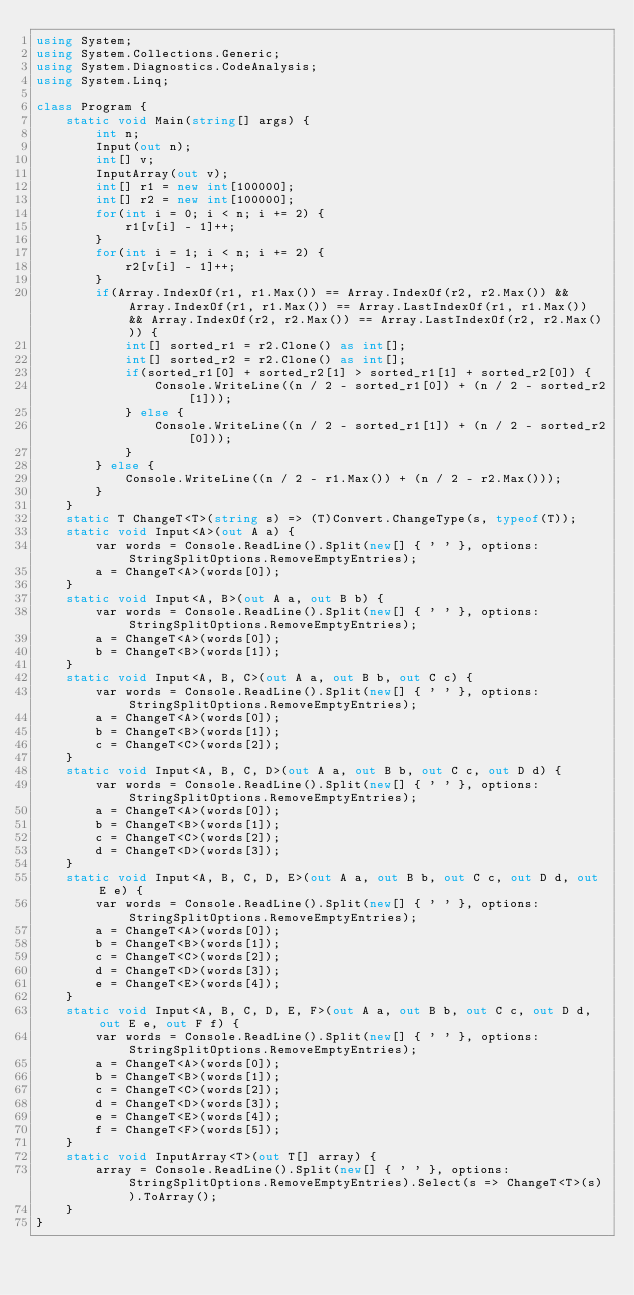<code> <loc_0><loc_0><loc_500><loc_500><_C#_>using System;
using System.Collections.Generic;
using System.Diagnostics.CodeAnalysis;
using System.Linq;

class Program {
    static void Main(string[] args) {
        int n;
        Input(out n);
        int[] v;
        InputArray(out v);
        int[] r1 = new int[100000];
        int[] r2 = new int[100000];
        for(int i = 0; i < n; i += 2) {
            r1[v[i] - 1]++;
        }
        for(int i = 1; i < n; i += 2) {
            r2[v[i] - 1]++;
        }
        if(Array.IndexOf(r1, r1.Max()) == Array.IndexOf(r2, r2.Max()) && Array.IndexOf(r1, r1.Max()) == Array.LastIndexOf(r1, r1.Max()) && Array.IndexOf(r2, r2.Max()) == Array.LastIndexOf(r2, r2.Max())) {
            int[] sorted_r1 = r2.Clone() as int[];
            int[] sorted_r2 = r2.Clone() as int[];
            if(sorted_r1[0] + sorted_r2[1] > sorted_r1[1] + sorted_r2[0]) {
                Console.WriteLine((n / 2 - sorted_r1[0]) + (n / 2 - sorted_r2[1]));
            } else {
                Console.WriteLine((n / 2 - sorted_r1[1]) + (n / 2 - sorted_r2[0]));
            }
        } else {
            Console.WriteLine((n / 2 - r1.Max()) + (n / 2 - r2.Max()));
        }
    }
    static T ChangeT<T>(string s) => (T)Convert.ChangeType(s, typeof(T));
    static void Input<A>(out A a) {
        var words = Console.ReadLine().Split(new[] { ' ' }, options: StringSplitOptions.RemoveEmptyEntries);
        a = ChangeT<A>(words[0]);
    }
    static void Input<A, B>(out A a, out B b) {
        var words = Console.ReadLine().Split(new[] { ' ' }, options: StringSplitOptions.RemoveEmptyEntries);
        a = ChangeT<A>(words[0]);
        b = ChangeT<B>(words[1]);
    }
    static void Input<A, B, C>(out A a, out B b, out C c) {
        var words = Console.ReadLine().Split(new[] { ' ' }, options: StringSplitOptions.RemoveEmptyEntries);
        a = ChangeT<A>(words[0]);
        b = ChangeT<B>(words[1]);
        c = ChangeT<C>(words[2]);
    }
    static void Input<A, B, C, D>(out A a, out B b, out C c, out D d) {
        var words = Console.ReadLine().Split(new[] { ' ' }, options: StringSplitOptions.RemoveEmptyEntries);
        a = ChangeT<A>(words[0]);
        b = ChangeT<B>(words[1]);
        c = ChangeT<C>(words[2]);
        d = ChangeT<D>(words[3]);
    }
    static void Input<A, B, C, D, E>(out A a, out B b, out C c, out D d, out E e) {
        var words = Console.ReadLine().Split(new[] { ' ' }, options: StringSplitOptions.RemoveEmptyEntries);
        a = ChangeT<A>(words[0]);
        b = ChangeT<B>(words[1]);
        c = ChangeT<C>(words[2]);
        d = ChangeT<D>(words[3]);
        e = ChangeT<E>(words[4]);
    }
    static void Input<A, B, C, D, E, F>(out A a, out B b, out C c, out D d, out E e, out F f) {
        var words = Console.ReadLine().Split(new[] { ' ' }, options: StringSplitOptions.RemoveEmptyEntries);
        a = ChangeT<A>(words[0]);
        b = ChangeT<B>(words[1]);
        c = ChangeT<C>(words[2]);
        d = ChangeT<D>(words[3]);
        e = ChangeT<E>(words[4]);
        f = ChangeT<F>(words[5]);
    }
    static void InputArray<T>(out T[] array) {
        array = Console.ReadLine().Split(new[] { ' ' }, options: StringSplitOptions.RemoveEmptyEntries).Select(s => ChangeT<T>(s)).ToArray();
    }
}</code> 